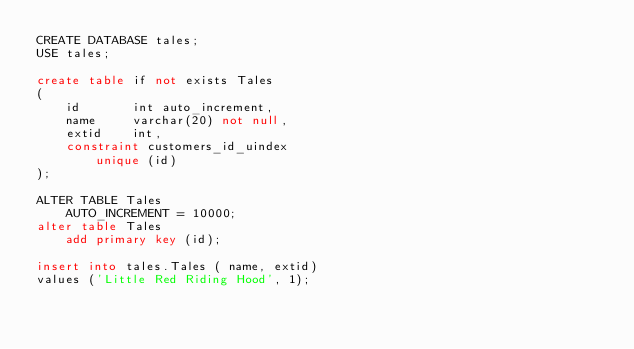<code> <loc_0><loc_0><loc_500><loc_500><_SQL_>CREATE DATABASE tales;
USE tales;

create table if not exists Tales
(
    id       int auto_increment,
    name     varchar(20) not null,
    extid    int,
    constraint customers_id_uindex
        unique (id)
);

ALTER TABLE Tales
    AUTO_INCREMENT = 10000;
alter table Tales
    add primary key (id);

insert into tales.Tales ( name, extid)
values ('Little Red Riding Hood', 1);</code> 